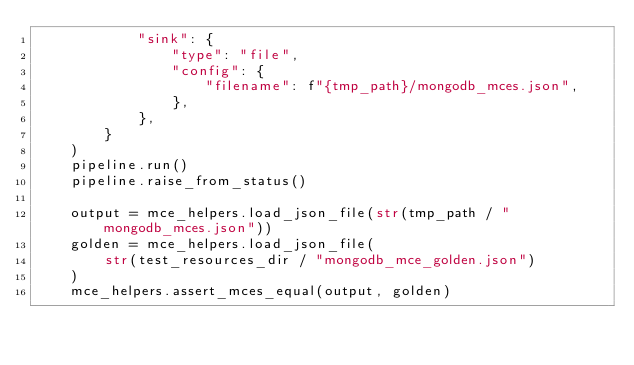<code> <loc_0><loc_0><loc_500><loc_500><_Python_>            "sink": {
                "type": "file",
                "config": {
                    "filename": f"{tmp_path}/mongodb_mces.json",
                },
            },
        }
    )
    pipeline.run()
    pipeline.raise_from_status()

    output = mce_helpers.load_json_file(str(tmp_path / "mongodb_mces.json"))
    golden = mce_helpers.load_json_file(
        str(test_resources_dir / "mongodb_mce_golden.json")
    )
    mce_helpers.assert_mces_equal(output, golden)
</code> 